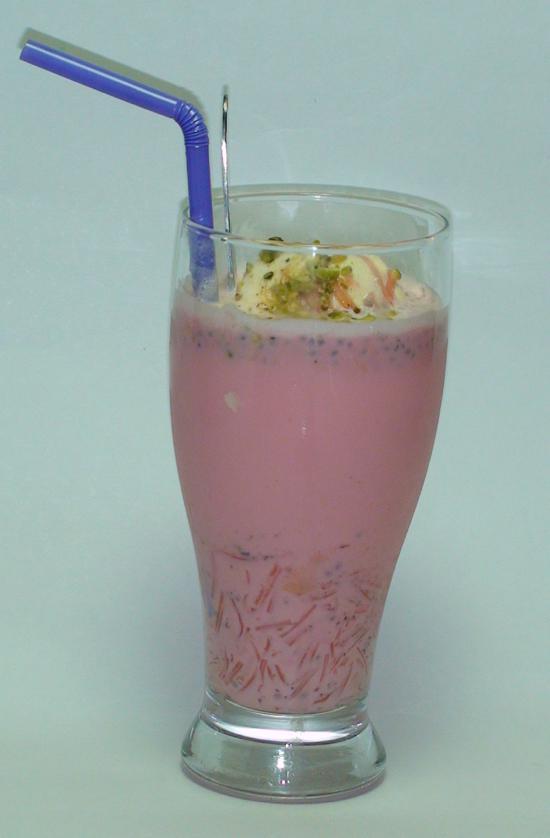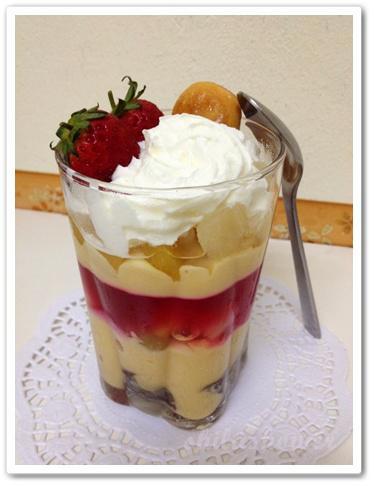The first image is the image on the left, the second image is the image on the right. Examine the images to the left and right. Is the description "There is at least one spoon visible." accurate? Answer yes or no. Yes. The first image is the image on the left, the second image is the image on the right. Analyze the images presented: Is the assertion "There are spoons near a dessert." valid? Answer yes or no. Yes. 